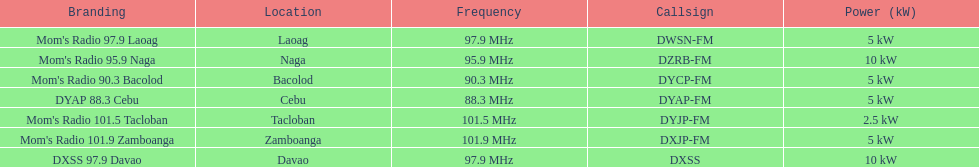In the power column, how many stations display 5 kw or greater? 6. 